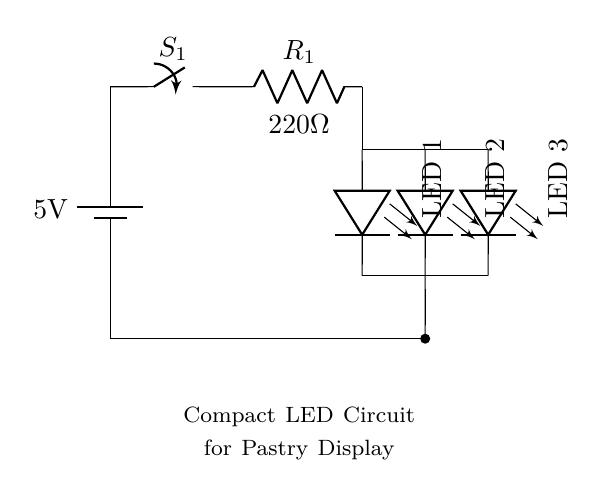What is the voltage supply for this circuit? The voltage supply is indicated right next to the battery symbol in the circuit diagram, which shows a potential difference of 5 volts.
Answer: 5 volts What type of component is S1? The component labeled S1 is a switch, as shown in the circuit diagram, which is used to control the flow of current in the circuit.
Answer: Switch How many LEDs are used in this circuit? The circuit diagram clearly shows three LED symbols in parallel, indicating there are three LEDs present in this circuit.
Answer: Three What is the resistance value of R1? The resistance value is displayed next to the resistor symbol, stating the resistance is 220 ohms in the circuit.
Answer: 220 ohms Why are the LEDs arranged in parallel? The LEDs are in parallel to ensure that each LED receives the same voltage from the power supply while allowing independent operation; one LED can fail without impacting the others.
Answer: To allow independent operation If one LED fails, how will it affect the others? In a parallel configuration, if one LED fails, the others will continue to operate normally because they are connected to the same voltage supply and not dependent on each other for current flow.
Answer: Others remain operational 